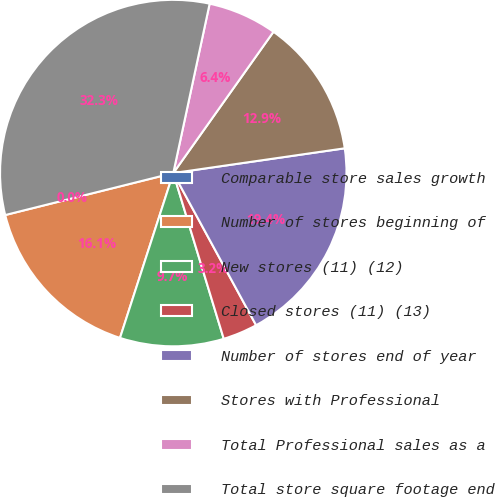Convert chart to OTSL. <chart><loc_0><loc_0><loc_500><loc_500><pie_chart><fcel>Comparable store sales growth<fcel>Number of stores beginning of<fcel>New stores (11) (12)<fcel>Closed stores (11) (13)<fcel>Number of stores end of year<fcel>Stores with Professional<fcel>Total Professional sales as a<fcel>Total store square footage end<nl><fcel>0.0%<fcel>16.13%<fcel>9.68%<fcel>3.23%<fcel>19.35%<fcel>12.9%<fcel>6.45%<fcel>32.26%<nl></chart> 